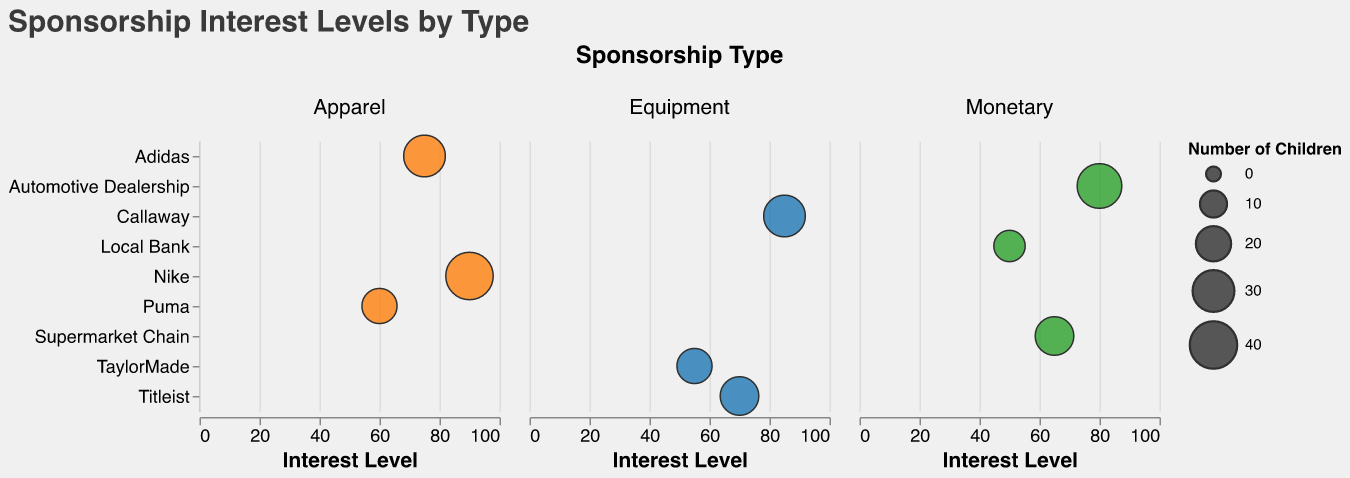What is the highest Interest Level recorded for an Apparel sponsor? The highest point on the Interest Level axis under the Apparel column will indicate this. The highest value under Apparel is 90, corresponding to Nike.
Answer: 90 Which Monetary sponsor has the highest Interest Level? Look under the Monetary column and check the highest point on the Interest Level axis. The Automotive Dealership has an Interest Level of 80.
Answer: Automotive Dealership How many children are associated with the Callaway sponsorship? The size of the bubble corresponding to Callaway represents the number of children. As per the data, it's associated with 30 children.
Answer: 30 Which Equipment sponsor has the lowest Interest Level? Under the Equipment column, compare the Interest Level values. TaylorMade has the lowest Interest Level of 55.
Answer: TaylorMade Which sponsorship type, on average, shows the highest interest level? Compute the average interest level for each sponsorship type - Equipment (85+55+70)/3, Apparel (90+75+60)/3, Monetary (50+65+80)/3. Compare these averages: Equipment is 70, Apparel is 75, Monetary is 65. Thus, Apparel has the highest average.
Answer: Apparel What is the total number of children associated with monetary sponsors? Sum the "Number_of_Children" for monetary sponsors: 15 (Local Bank) + 25 (Supermarket Chain) + 35 (Automotive Dealership) = 75.
Answer: 75 Which sponsor is associated with the largest number of children? The bubble with the largest size will indicate this. Nike, under Apparel, has the largest number of associated children (40).
Answer: Nike Compare the interest levels for Adidas and Puma. Which is higher and by how much? Adidas has an Interest Level of 75, while Puma has 60. The difference is 75 - 60 = 15.
Answer: Adidas by 15 Among the sponsors listed, which has the highest interest level and how many children are associated with it? Locate the point with the highest Interest Level. The highest Interest Level is 90 for Nike which is associated with 40 children.
Answer: Nike, 40 children 